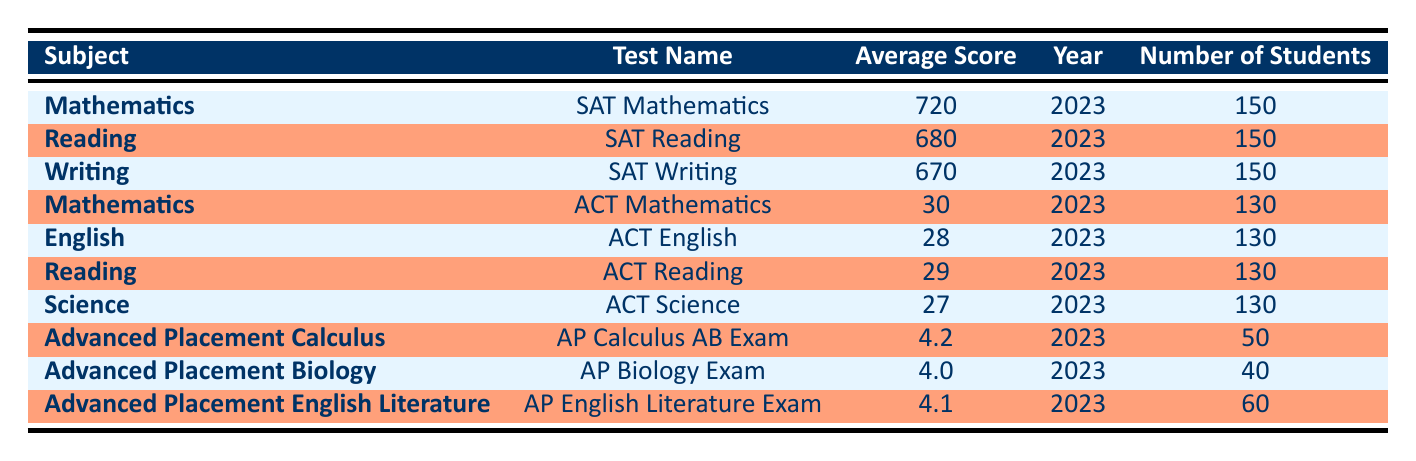What is the average score of Beechwood High School students in SAT Mathematics? The SAT Mathematics average score listed in the table is 720 for the year 2023.
Answer: 720 How many students took the ACT Science exam? The table indicates that 130 students took the ACT Science exam.
Answer: 130 Which subject had the highest average score in AP exams? The table shows that the highest average score in AP exams is 4.2 in Advanced Placement Calculus.
Answer: 4.2 What is the total number of students who took the ACT exams? The total number of students who took the ACT exams can be calculated by summing the number of students for each ACT subject: 130 (Mathematics) + 130 (English) + 130 (Reading) + 130 (Science) = 520.
Answer: 520 Is the average score for SAT Reading higher than that of ACT Reading? Yes, the average score for SAT Reading is 680, while the average for ACT Reading is 29. Therefore, SAT Reading is higher.
Answer: Yes What was the average score for Advanced Placement Biology? According to the table, the average score for Advanced Placement Biology is 4.0 for the year 2023.
Answer: 4.0 How do the average scores of ACT Mathematics and ACT English compare? The average score for ACT Mathematics is 30, and for ACT English, it is 28. Since 30 is greater than 28, ACT Mathematics has a higher average score.
Answer: ACT Mathematics is higher Which subject had fewer students taking the exam, AP Calculus or AP Biology? The table shows that AP Calculus had 50 students, while AP Biology had 40 students. Therefore, AP Biology had fewer students.
Answer: AP Biology had fewer students 